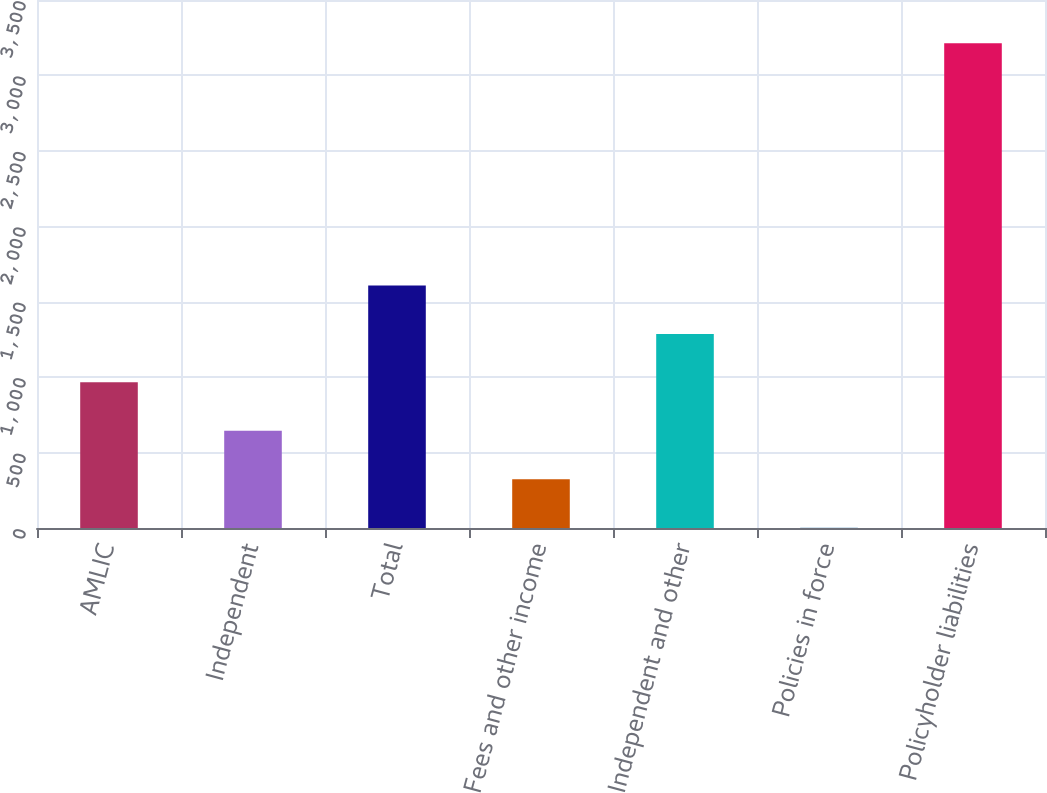<chart> <loc_0><loc_0><loc_500><loc_500><bar_chart><fcel>AMLIC<fcel>Independent<fcel>Total<fcel>Fees and other income<fcel>Independent and other<fcel>Policies in force<fcel>Policyholder liabilities<nl><fcel>965.4<fcel>644.17<fcel>1607.86<fcel>322.94<fcel>1286.63<fcel>1.71<fcel>3214<nl></chart> 